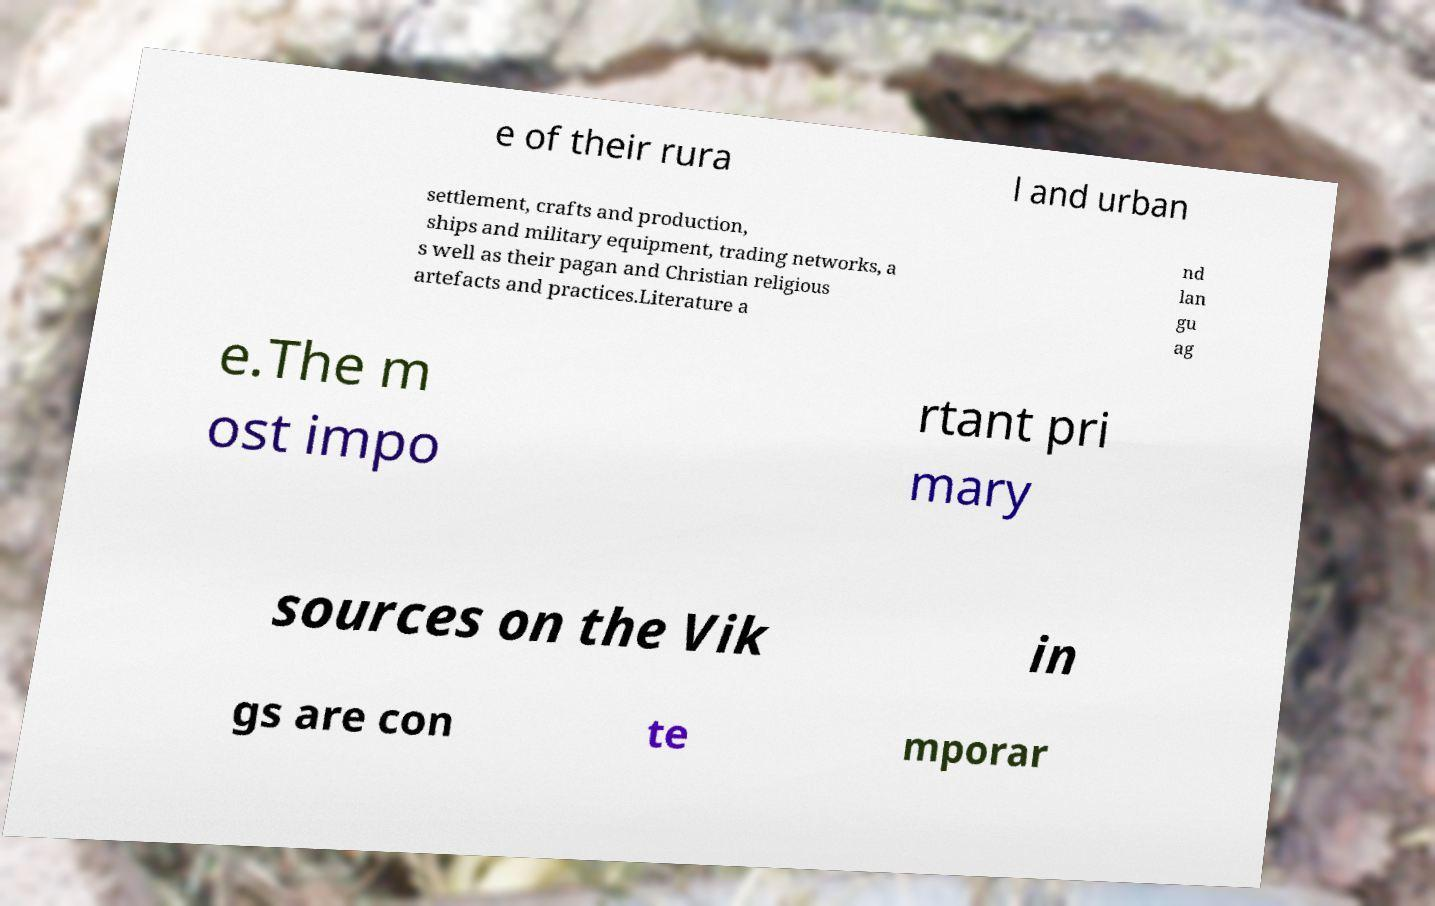There's text embedded in this image that I need extracted. Can you transcribe it verbatim? e of their rura l and urban settlement, crafts and production, ships and military equipment, trading networks, a s well as their pagan and Christian religious artefacts and practices.Literature a nd lan gu ag e.The m ost impo rtant pri mary sources on the Vik in gs are con te mporar 